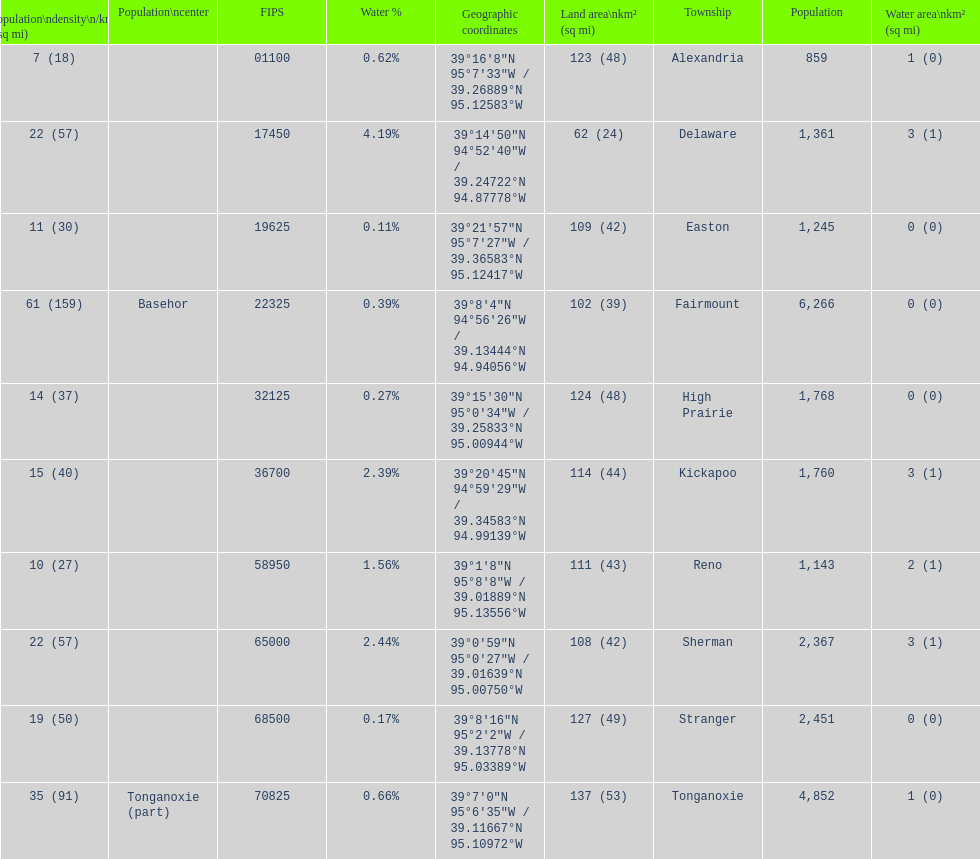What is the difference of population in easton and reno? 102. 